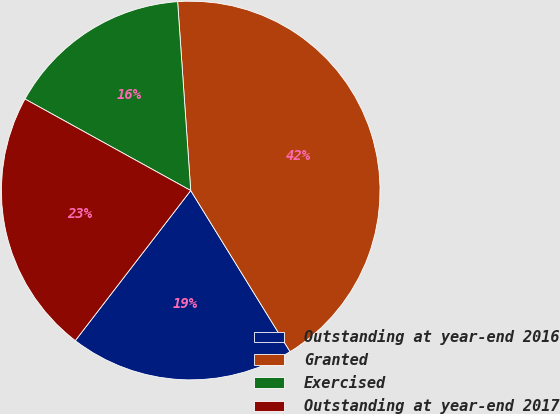<chart> <loc_0><loc_0><loc_500><loc_500><pie_chart><fcel>Outstanding at year-end 2016<fcel>Granted<fcel>Exercised<fcel>Outstanding at year-end 2017<nl><fcel>19.23%<fcel>42.31%<fcel>15.87%<fcel>22.6%<nl></chart> 